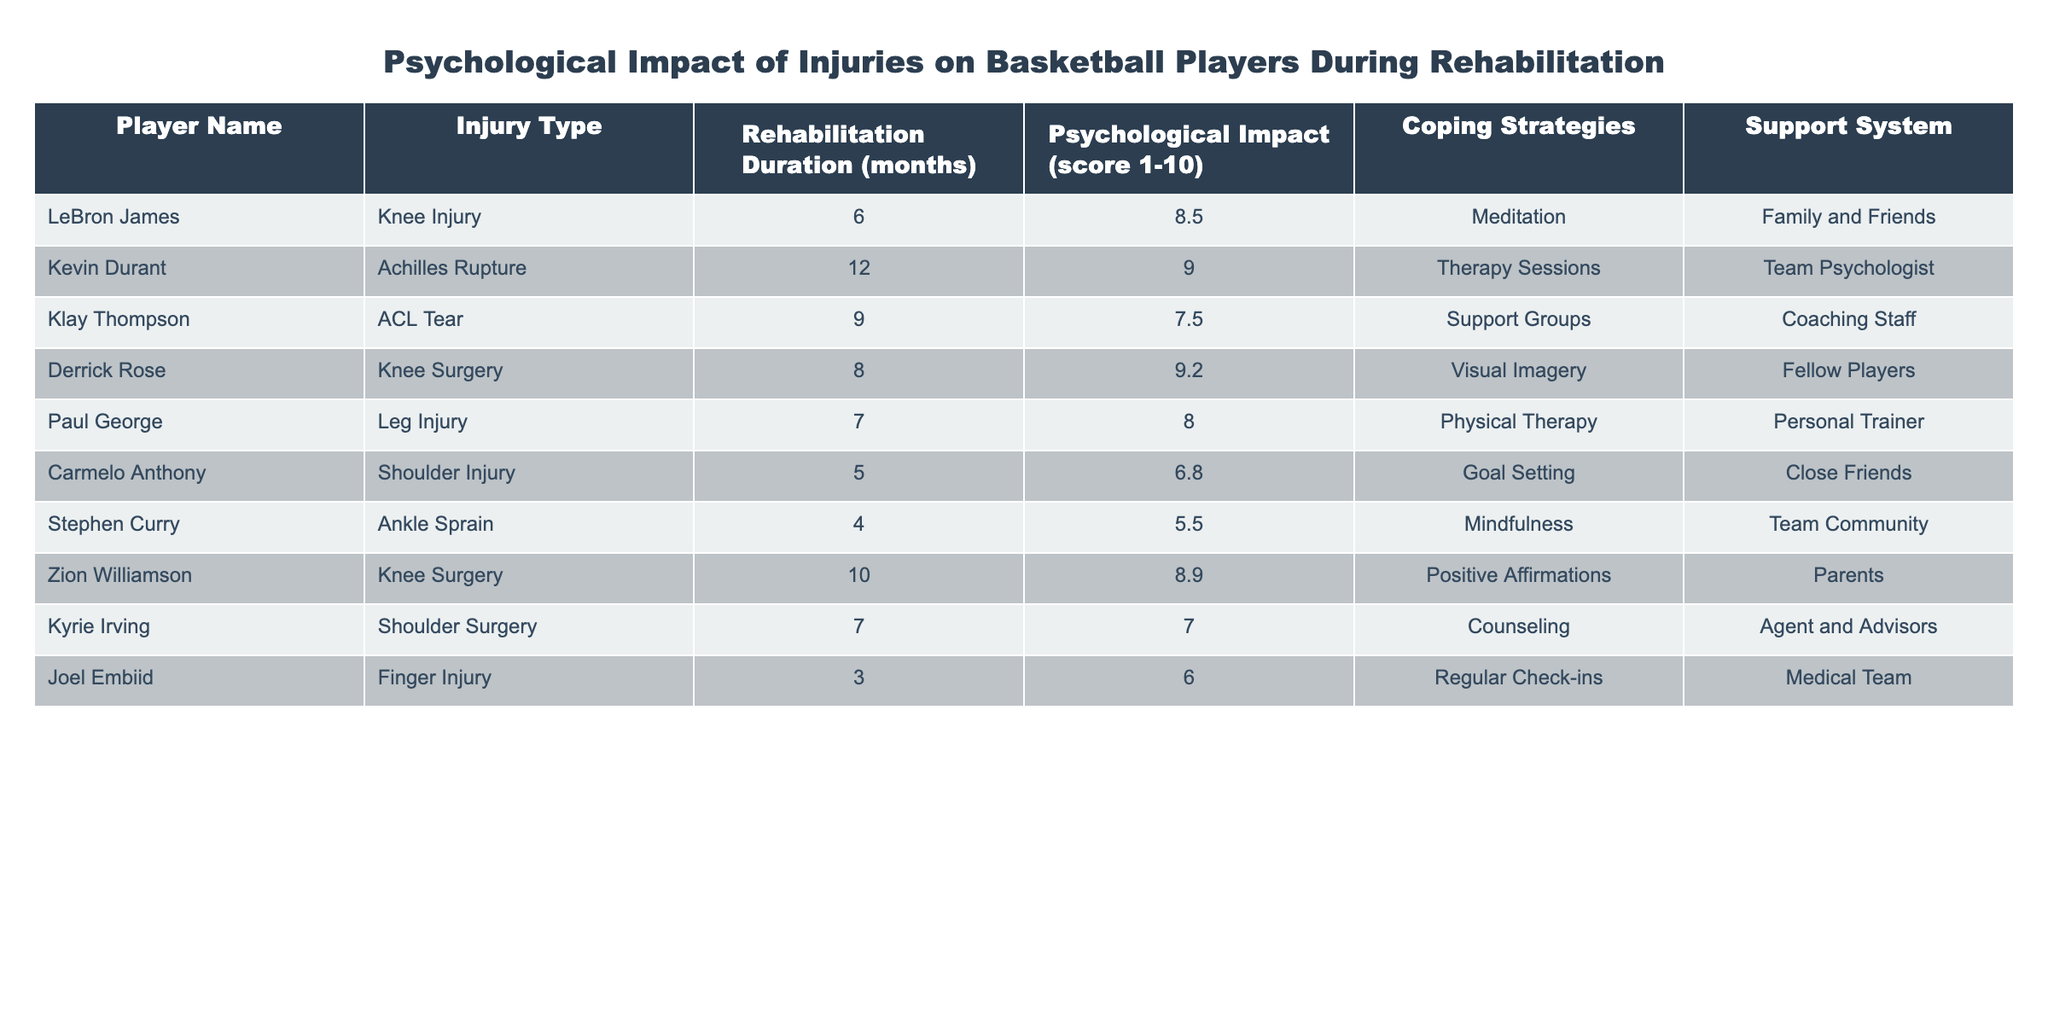What is the psychological impact score of Kevin Durant? By locating the row for Kevin Durant, we can see that the Psychological Impact score is listed as 9.0.
Answer: 9.0 Which player had the longest rehabilitation duration? Examining the Rehabilitation Duration column, Kevin Durant's duration is 12 months, which is the highest compared to other players.
Answer: 12 months What coping strategy did LeBron James use? Referring to LeBron James's row in the table, the coping strategy listed is Meditation.
Answer: Meditation Is the psychological impact score of Klay Thompson greater than 8? Klay Thompson's score is 7.5, which is less than 8, so the answer is no.
Answer: No What is the average psychological impact score of players with shoulder injuries? First, identify the players with shoulder injuries: Carmelo Anthony and Kyrie Irving, whose scores are 6.8 and 7.0 respectively. Calculate the average: (6.8 + 7.0) / 2 = 6.9.
Answer: 6.9 Which player utilized counseling as a coping strategy? Looking at the table, Kyrie Irving is the player listed who used Counseling as a coping strategy.
Answer: Kyrie Irving Compare the rehabilitation duration and psychological impact for players with knee injuries. Who has a higher psychological score? The players with knee injuries are LeBron James (6 months, score 8.5), Derrick Rose (8 months, score 9.2), and Zion Williamson (10 months, score 8.9). Derrick Rose has the highest psychological score of 9.2.
Answer: Derrick Rose Does any player report a psychological impact score below 7? Checking the scores, Carmelo Anthony has 6.8, which is below 7, making the answer yes.
Answer: Yes What is the support system of Zion Williamson? The support system for Zion Williamson, as seen in the table, is listed as Parents.
Answer: Parents 